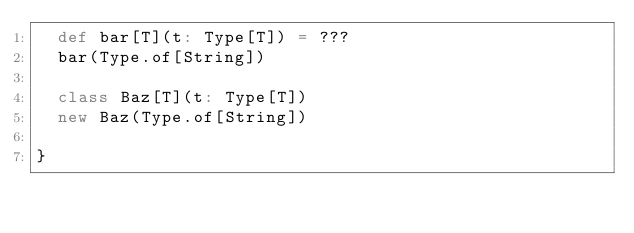<code> <loc_0><loc_0><loc_500><loc_500><_Scala_>  def bar[T](t: Type[T]) = ???
  bar(Type.of[String])

  class Baz[T](t: Type[T])
  new Baz(Type.of[String])

}
</code> 